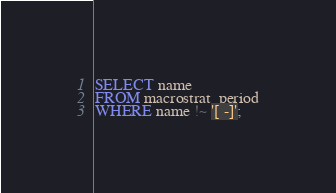<code> <loc_0><loc_0><loc_500><loc_500><_SQL_>SELECT name
FROM macrostrat_period
WHERE name !~ '[ -]';
</code> 